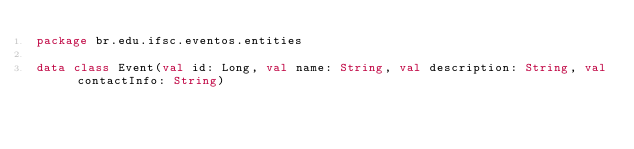<code> <loc_0><loc_0><loc_500><loc_500><_Kotlin_>package br.edu.ifsc.eventos.entities

data class Event(val id: Long, val name: String, val description: String, val contactInfo: String)</code> 